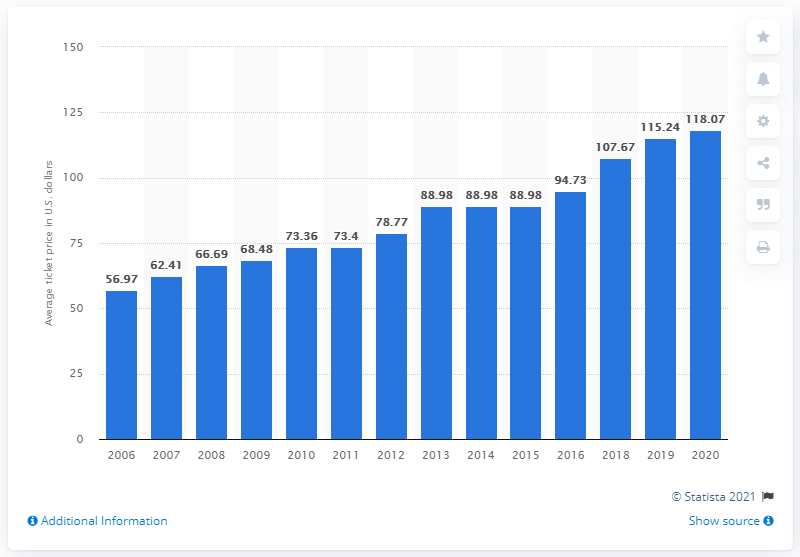Specify some key components in this picture. In 2020, the average ticket price for a Houston Texans game was $118.07. 